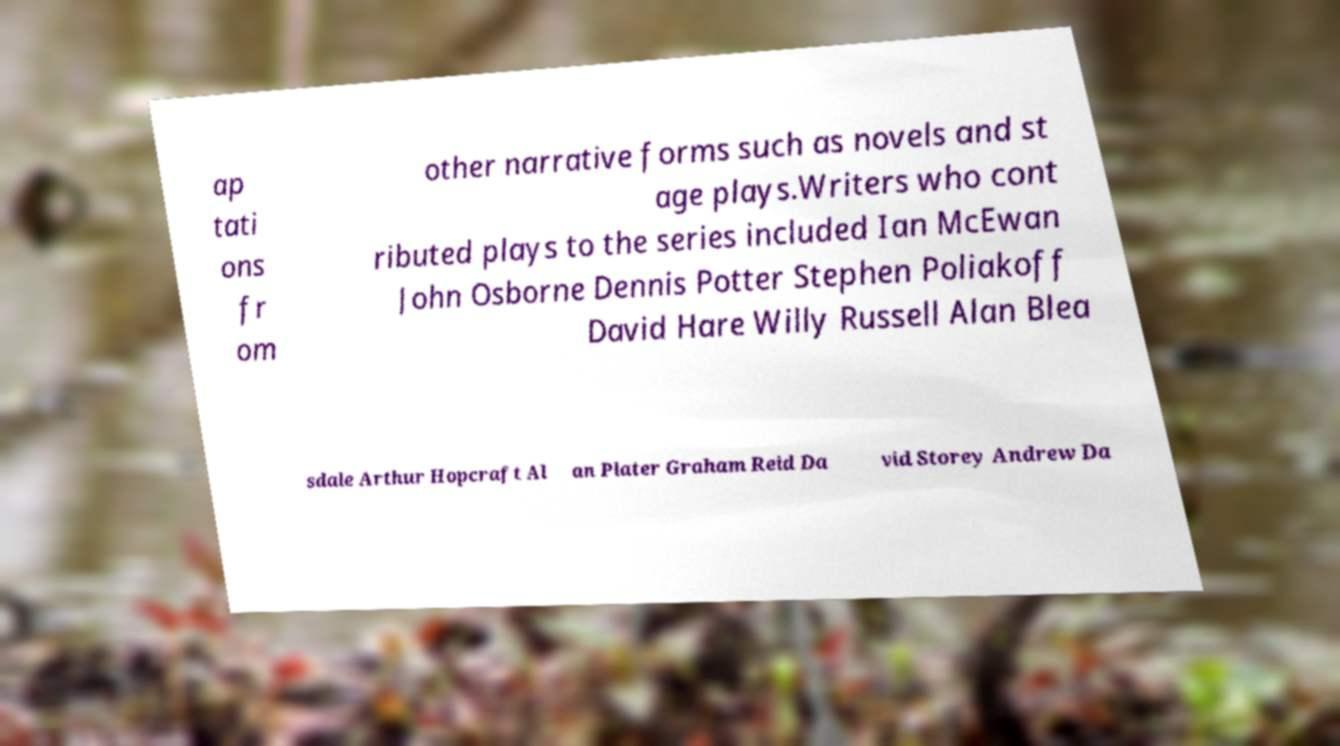Can you read and provide the text displayed in the image?This photo seems to have some interesting text. Can you extract and type it out for me? ap tati ons fr om other narrative forms such as novels and st age plays.Writers who cont ributed plays to the series included Ian McEwan John Osborne Dennis Potter Stephen Poliakoff David Hare Willy Russell Alan Blea sdale Arthur Hopcraft Al an Plater Graham Reid Da vid Storey Andrew Da 